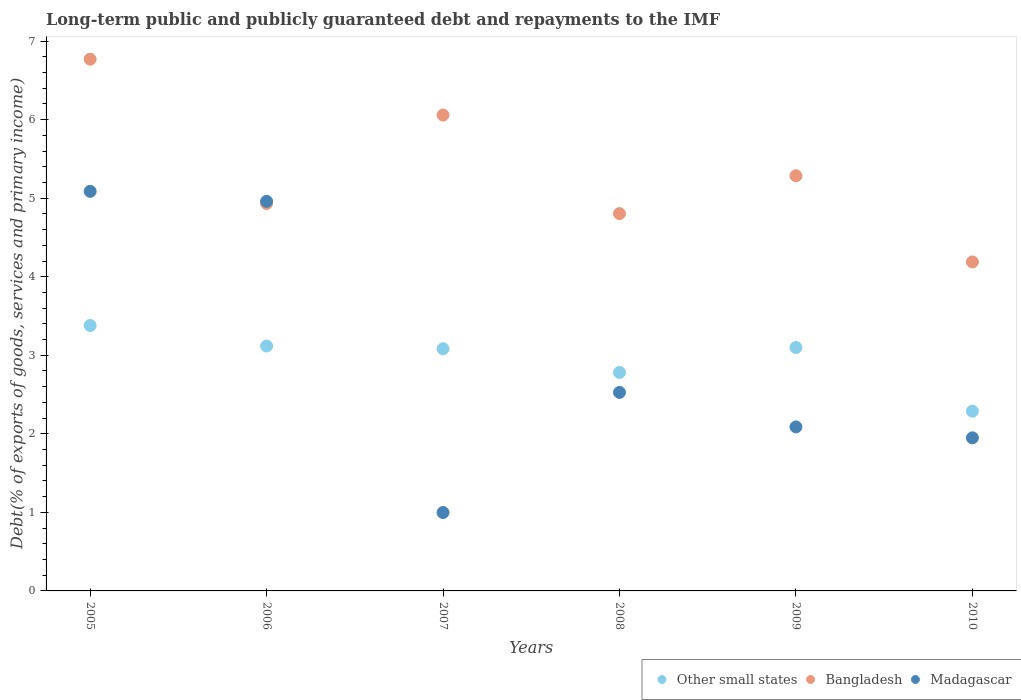What is the debt and repayments in Other small states in 2005?
Ensure brevity in your answer.  3.38. Across all years, what is the maximum debt and repayments in Other small states?
Provide a short and direct response. 3.38. Across all years, what is the minimum debt and repayments in Madagascar?
Provide a succinct answer. 1. In which year was the debt and repayments in Madagascar maximum?
Provide a succinct answer. 2005. What is the total debt and repayments in Other small states in the graph?
Make the answer very short. 17.75. What is the difference between the debt and repayments in Madagascar in 2006 and that in 2008?
Provide a succinct answer. 2.43. What is the difference between the debt and repayments in Other small states in 2006 and the debt and repayments in Bangladesh in 2005?
Offer a terse response. -3.65. What is the average debt and repayments in Madagascar per year?
Give a very brief answer. 2.93. In the year 2005, what is the difference between the debt and repayments in Other small states and debt and repayments in Bangladesh?
Make the answer very short. -3.39. What is the ratio of the debt and repayments in Other small states in 2006 to that in 2008?
Provide a short and direct response. 1.12. Is the debt and repayments in Bangladesh in 2007 less than that in 2008?
Offer a very short reply. No. Is the difference between the debt and repayments in Other small states in 2005 and 2010 greater than the difference between the debt and repayments in Bangladesh in 2005 and 2010?
Give a very brief answer. No. What is the difference between the highest and the second highest debt and repayments in Madagascar?
Provide a short and direct response. 0.13. What is the difference between the highest and the lowest debt and repayments in Bangladesh?
Make the answer very short. 2.58. Is the sum of the debt and repayments in Other small states in 2005 and 2010 greater than the maximum debt and repayments in Madagascar across all years?
Provide a short and direct response. Yes. Is it the case that in every year, the sum of the debt and repayments in Madagascar and debt and repayments in Other small states  is greater than the debt and repayments in Bangladesh?
Make the answer very short. No. Is the debt and repayments in Madagascar strictly less than the debt and repayments in Other small states over the years?
Keep it short and to the point. No. How many dotlines are there?
Your response must be concise. 3. What is the difference between two consecutive major ticks on the Y-axis?
Offer a terse response. 1. Are the values on the major ticks of Y-axis written in scientific E-notation?
Keep it short and to the point. No. Does the graph contain any zero values?
Offer a very short reply. No. Does the graph contain grids?
Offer a very short reply. No. What is the title of the graph?
Keep it short and to the point. Long-term public and publicly guaranteed debt and repayments to the IMF. What is the label or title of the X-axis?
Provide a succinct answer. Years. What is the label or title of the Y-axis?
Keep it short and to the point. Debt(% of exports of goods, services and primary income). What is the Debt(% of exports of goods, services and primary income) of Other small states in 2005?
Ensure brevity in your answer.  3.38. What is the Debt(% of exports of goods, services and primary income) of Bangladesh in 2005?
Make the answer very short. 6.77. What is the Debt(% of exports of goods, services and primary income) of Madagascar in 2005?
Offer a very short reply. 5.09. What is the Debt(% of exports of goods, services and primary income) of Other small states in 2006?
Ensure brevity in your answer.  3.12. What is the Debt(% of exports of goods, services and primary income) of Bangladesh in 2006?
Provide a succinct answer. 4.93. What is the Debt(% of exports of goods, services and primary income) in Madagascar in 2006?
Make the answer very short. 4.96. What is the Debt(% of exports of goods, services and primary income) in Other small states in 2007?
Offer a very short reply. 3.08. What is the Debt(% of exports of goods, services and primary income) in Bangladesh in 2007?
Your answer should be very brief. 6.06. What is the Debt(% of exports of goods, services and primary income) in Madagascar in 2007?
Make the answer very short. 1. What is the Debt(% of exports of goods, services and primary income) in Other small states in 2008?
Offer a terse response. 2.78. What is the Debt(% of exports of goods, services and primary income) in Bangladesh in 2008?
Offer a very short reply. 4.8. What is the Debt(% of exports of goods, services and primary income) of Madagascar in 2008?
Your answer should be compact. 2.53. What is the Debt(% of exports of goods, services and primary income) in Other small states in 2009?
Ensure brevity in your answer.  3.1. What is the Debt(% of exports of goods, services and primary income) in Bangladesh in 2009?
Provide a short and direct response. 5.29. What is the Debt(% of exports of goods, services and primary income) of Madagascar in 2009?
Your answer should be very brief. 2.09. What is the Debt(% of exports of goods, services and primary income) of Other small states in 2010?
Provide a succinct answer. 2.29. What is the Debt(% of exports of goods, services and primary income) in Bangladesh in 2010?
Provide a succinct answer. 4.19. What is the Debt(% of exports of goods, services and primary income) of Madagascar in 2010?
Provide a short and direct response. 1.95. Across all years, what is the maximum Debt(% of exports of goods, services and primary income) in Other small states?
Provide a short and direct response. 3.38. Across all years, what is the maximum Debt(% of exports of goods, services and primary income) in Bangladesh?
Your response must be concise. 6.77. Across all years, what is the maximum Debt(% of exports of goods, services and primary income) in Madagascar?
Your answer should be compact. 5.09. Across all years, what is the minimum Debt(% of exports of goods, services and primary income) in Other small states?
Provide a short and direct response. 2.29. Across all years, what is the minimum Debt(% of exports of goods, services and primary income) of Bangladesh?
Give a very brief answer. 4.19. Across all years, what is the minimum Debt(% of exports of goods, services and primary income) of Madagascar?
Provide a short and direct response. 1. What is the total Debt(% of exports of goods, services and primary income) of Other small states in the graph?
Provide a short and direct response. 17.75. What is the total Debt(% of exports of goods, services and primary income) of Bangladesh in the graph?
Keep it short and to the point. 32.04. What is the total Debt(% of exports of goods, services and primary income) in Madagascar in the graph?
Your answer should be compact. 17.61. What is the difference between the Debt(% of exports of goods, services and primary income) in Other small states in 2005 and that in 2006?
Provide a short and direct response. 0.26. What is the difference between the Debt(% of exports of goods, services and primary income) in Bangladesh in 2005 and that in 2006?
Ensure brevity in your answer.  1.84. What is the difference between the Debt(% of exports of goods, services and primary income) of Madagascar in 2005 and that in 2006?
Give a very brief answer. 0.13. What is the difference between the Debt(% of exports of goods, services and primary income) in Other small states in 2005 and that in 2007?
Your response must be concise. 0.3. What is the difference between the Debt(% of exports of goods, services and primary income) of Bangladesh in 2005 and that in 2007?
Your response must be concise. 0.71. What is the difference between the Debt(% of exports of goods, services and primary income) of Madagascar in 2005 and that in 2007?
Provide a short and direct response. 4.09. What is the difference between the Debt(% of exports of goods, services and primary income) of Other small states in 2005 and that in 2008?
Ensure brevity in your answer.  0.6. What is the difference between the Debt(% of exports of goods, services and primary income) in Bangladesh in 2005 and that in 2008?
Your answer should be compact. 1.97. What is the difference between the Debt(% of exports of goods, services and primary income) of Madagascar in 2005 and that in 2008?
Ensure brevity in your answer.  2.56. What is the difference between the Debt(% of exports of goods, services and primary income) in Other small states in 2005 and that in 2009?
Make the answer very short. 0.28. What is the difference between the Debt(% of exports of goods, services and primary income) of Bangladesh in 2005 and that in 2009?
Keep it short and to the point. 1.48. What is the difference between the Debt(% of exports of goods, services and primary income) of Madagascar in 2005 and that in 2009?
Offer a very short reply. 3. What is the difference between the Debt(% of exports of goods, services and primary income) of Other small states in 2005 and that in 2010?
Your response must be concise. 1.09. What is the difference between the Debt(% of exports of goods, services and primary income) in Bangladesh in 2005 and that in 2010?
Your answer should be compact. 2.58. What is the difference between the Debt(% of exports of goods, services and primary income) in Madagascar in 2005 and that in 2010?
Provide a succinct answer. 3.14. What is the difference between the Debt(% of exports of goods, services and primary income) in Other small states in 2006 and that in 2007?
Give a very brief answer. 0.03. What is the difference between the Debt(% of exports of goods, services and primary income) in Bangladesh in 2006 and that in 2007?
Offer a terse response. -1.13. What is the difference between the Debt(% of exports of goods, services and primary income) in Madagascar in 2006 and that in 2007?
Your response must be concise. 3.96. What is the difference between the Debt(% of exports of goods, services and primary income) in Other small states in 2006 and that in 2008?
Keep it short and to the point. 0.34. What is the difference between the Debt(% of exports of goods, services and primary income) of Bangladesh in 2006 and that in 2008?
Offer a very short reply. 0.13. What is the difference between the Debt(% of exports of goods, services and primary income) of Madagascar in 2006 and that in 2008?
Provide a short and direct response. 2.43. What is the difference between the Debt(% of exports of goods, services and primary income) in Other small states in 2006 and that in 2009?
Your answer should be compact. 0.02. What is the difference between the Debt(% of exports of goods, services and primary income) of Bangladesh in 2006 and that in 2009?
Give a very brief answer. -0.35. What is the difference between the Debt(% of exports of goods, services and primary income) in Madagascar in 2006 and that in 2009?
Offer a very short reply. 2.87. What is the difference between the Debt(% of exports of goods, services and primary income) in Other small states in 2006 and that in 2010?
Give a very brief answer. 0.83. What is the difference between the Debt(% of exports of goods, services and primary income) of Bangladesh in 2006 and that in 2010?
Your answer should be compact. 0.74. What is the difference between the Debt(% of exports of goods, services and primary income) in Madagascar in 2006 and that in 2010?
Keep it short and to the point. 3.01. What is the difference between the Debt(% of exports of goods, services and primary income) of Other small states in 2007 and that in 2008?
Offer a very short reply. 0.3. What is the difference between the Debt(% of exports of goods, services and primary income) of Bangladesh in 2007 and that in 2008?
Keep it short and to the point. 1.25. What is the difference between the Debt(% of exports of goods, services and primary income) of Madagascar in 2007 and that in 2008?
Your answer should be very brief. -1.53. What is the difference between the Debt(% of exports of goods, services and primary income) in Other small states in 2007 and that in 2009?
Your answer should be very brief. -0.02. What is the difference between the Debt(% of exports of goods, services and primary income) in Bangladesh in 2007 and that in 2009?
Offer a very short reply. 0.77. What is the difference between the Debt(% of exports of goods, services and primary income) of Madagascar in 2007 and that in 2009?
Give a very brief answer. -1.09. What is the difference between the Debt(% of exports of goods, services and primary income) of Other small states in 2007 and that in 2010?
Ensure brevity in your answer.  0.79. What is the difference between the Debt(% of exports of goods, services and primary income) of Bangladesh in 2007 and that in 2010?
Offer a very short reply. 1.87. What is the difference between the Debt(% of exports of goods, services and primary income) of Madagascar in 2007 and that in 2010?
Offer a very short reply. -0.95. What is the difference between the Debt(% of exports of goods, services and primary income) of Other small states in 2008 and that in 2009?
Your answer should be very brief. -0.32. What is the difference between the Debt(% of exports of goods, services and primary income) of Bangladesh in 2008 and that in 2009?
Your answer should be very brief. -0.48. What is the difference between the Debt(% of exports of goods, services and primary income) in Madagascar in 2008 and that in 2009?
Provide a succinct answer. 0.44. What is the difference between the Debt(% of exports of goods, services and primary income) of Other small states in 2008 and that in 2010?
Offer a very short reply. 0.49. What is the difference between the Debt(% of exports of goods, services and primary income) of Bangladesh in 2008 and that in 2010?
Your answer should be compact. 0.62. What is the difference between the Debt(% of exports of goods, services and primary income) in Madagascar in 2008 and that in 2010?
Give a very brief answer. 0.58. What is the difference between the Debt(% of exports of goods, services and primary income) of Other small states in 2009 and that in 2010?
Provide a succinct answer. 0.81. What is the difference between the Debt(% of exports of goods, services and primary income) of Bangladesh in 2009 and that in 2010?
Make the answer very short. 1.1. What is the difference between the Debt(% of exports of goods, services and primary income) of Madagascar in 2009 and that in 2010?
Provide a succinct answer. 0.14. What is the difference between the Debt(% of exports of goods, services and primary income) of Other small states in 2005 and the Debt(% of exports of goods, services and primary income) of Bangladesh in 2006?
Provide a short and direct response. -1.55. What is the difference between the Debt(% of exports of goods, services and primary income) in Other small states in 2005 and the Debt(% of exports of goods, services and primary income) in Madagascar in 2006?
Your response must be concise. -1.58. What is the difference between the Debt(% of exports of goods, services and primary income) in Bangladesh in 2005 and the Debt(% of exports of goods, services and primary income) in Madagascar in 2006?
Keep it short and to the point. 1.81. What is the difference between the Debt(% of exports of goods, services and primary income) of Other small states in 2005 and the Debt(% of exports of goods, services and primary income) of Bangladesh in 2007?
Your response must be concise. -2.68. What is the difference between the Debt(% of exports of goods, services and primary income) of Other small states in 2005 and the Debt(% of exports of goods, services and primary income) of Madagascar in 2007?
Provide a short and direct response. 2.38. What is the difference between the Debt(% of exports of goods, services and primary income) of Bangladesh in 2005 and the Debt(% of exports of goods, services and primary income) of Madagascar in 2007?
Your response must be concise. 5.77. What is the difference between the Debt(% of exports of goods, services and primary income) of Other small states in 2005 and the Debt(% of exports of goods, services and primary income) of Bangladesh in 2008?
Your answer should be compact. -1.42. What is the difference between the Debt(% of exports of goods, services and primary income) of Other small states in 2005 and the Debt(% of exports of goods, services and primary income) of Madagascar in 2008?
Your answer should be very brief. 0.85. What is the difference between the Debt(% of exports of goods, services and primary income) of Bangladesh in 2005 and the Debt(% of exports of goods, services and primary income) of Madagascar in 2008?
Ensure brevity in your answer.  4.24. What is the difference between the Debt(% of exports of goods, services and primary income) of Other small states in 2005 and the Debt(% of exports of goods, services and primary income) of Bangladesh in 2009?
Offer a very short reply. -1.91. What is the difference between the Debt(% of exports of goods, services and primary income) of Other small states in 2005 and the Debt(% of exports of goods, services and primary income) of Madagascar in 2009?
Offer a very short reply. 1.29. What is the difference between the Debt(% of exports of goods, services and primary income) in Bangladesh in 2005 and the Debt(% of exports of goods, services and primary income) in Madagascar in 2009?
Provide a short and direct response. 4.68. What is the difference between the Debt(% of exports of goods, services and primary income) of Other small states in 2005 and the Debt(% of exports of goods, services and primary income) of Bangladesh in 2010?
Provide a short and direct response. -0.81. What is the difference between the Debt(% of exports of goods, services and primary income) of Other small states in 2005 and the Debt(% of exports of goods, services and primary income) of Madagascar in 2010?
Your answer should be very brief. 1.43. What is the difference between the Debt(% of exports of goods, services and primary income) in Bangladesh in 2005 and the Debt(% of exports of goods, services and primary income) in Madagascar in 2010?
Make the answer very short. 4.82. What is the difference between the Debt(% of exports of goods, services and primary income) of Other small states in 2006 and the Debt(% of exports of goods, services and primary income) of Bangladesh in 2007?
Make the answer very short. -2.94. What is the difference between the Debt(% of exports of goods, services and primary income) in Other small states in 2006 and the Debt(% of exports of goods, services and primary income) in Madagascar in 2007?
Your response must be concise. 2.12. What is the difference between the Debt(% of exports of goods, services and primary income) of Bangladesh in 2006 and the Debt(% of exports of goods, services and primary income) of Madagascar in 2007?
Ensure brevity in your answer.  3.93. What is the difference between the Debt(% of exports of goods, services and primary income) of Other small states in 2006 and the Debt(% of exports of goods, services and primary income) of Bangladesh in 2008?
Provide a short and direct response. -1.69. What is the difference between the Debt(% of exports of goods, services and primary income) of Other small states in 2006 and the Debt(% of exports of goods, services and primary income) of Madagascar in 2008?
Offer a very short reply. 0.59. What is the difference between the Debt(% of exports of goods, services and primary income) of Bangladesh in 2006 and the Debt(% of exports of goods, services and primary income) of Madagascar in 2008?
Ensure brevity in your answer.  2.41. What is the difference between the Debt(% of exports of goods, services and primary income) in Other small states in 2006 and the Debt(% of exports of goods, services and primary income) in Bangladesh in 2009?
Provide a short and direct response. -2.17. What is the difference between the Debt(% of exports of goods, services and primary income) in Other small states in 2006 and the Debt(% of exports of goods, services and primary income) in Madagascar in 2009?
Your response must be concise. 1.03. What is the difference between the Debt(% of exports of goods, services and primary income) in Bangladesh in 2006 and the Debt(% of exports of goods, services and primary income) in Madagascar in 2009?
Make the answer very short. 2.84. What is the difference between the Debt(% of exports of goods, services and primary income) in Other small states in 2006 and the Debt(% of exports of goods, services and primary income) in Bangladesh in 2010?
Your answer should be very brief. -1.07. What is the difference between the Debt(% of exports of goods, services and primary income) in Other small states in 2006 and the Debt(% of exports of goods, services and primary income) in Madagascar in 2010?
Offer a terse response. 1.17. What is the difference between the Debt(% of exports of goods, services and primary income) of Bangladesh in 2006 and the Debt(% of exports of goods, services and primary income) of Madagascar in 2010?
Provide a succinct answer. 2.98. What is the difference between the Debt(% of exports of goods, services and primary income) in Other small states in 2007 and the Debt(% of exports of goods, services and primary income) in Bangladesh in 2008?
Make the answer very short. -1.72. What is the difference between the Debt(% of exports of goods, services and primary income) in Other small states in 2007 and the Debt(% of exports of goods, services and primary income) in Madagascar in 2008?
Your response must be concise. 0.56. What is the difference between the Debt(% of exports of goods, services and primary income) of Bangladesh in 2007 and the Debt(% of exports of goods, services and primary income) of Madagascar in 2008?
Offer a very short reply. 3.53. What is the difference between the Debt(% of exports of goods, services and primary income) in Other small states in 2007 and the Debt(% of exports of goods, services and primary income) in Bangladesh in 2009?
Give a very brief answer. -2.2. What is the difference between the Debt(% of exports of goods, services and primary income) in Other small states in 2007 and the Debt(% of exports of goods, services and primary income) in Madagascar in 2009?
Your response must be concise. 1. What is the difference between the Debt(% of exports of goods, services and primary income) of Bangladesh in 2007 and the Debt(% of exports of goods, services and primary income) of Madagascar in 2009?
Ensure brevity in your answer.  3.97. What is the difference between the Debt(% of exports of goods, services and primary income) of Other small states in 2007 and the Debt(% of exports of goods, services and primary income) of Bangladesh in 2010?
Your answer should be very brief. -1.11. What is the difference between the Debt(% of exports of goods, services and primary income) in Other small states in 2007 and the Debt(% of exports of goods, services and primary income) in Madagascar in 2010?
Your response must be concise. 1.13. What is the difference between the Debt(% of exports of goods, services and primary income) of Bangladesh in 2007 and the Debt(% of exports of goods, services and primary income) of Madagascar in 2010?
Your response must be concise. 4.11. What is the difference between the Debt(% of exports of goods, services and primary income) in Other small states in 2008 and the Debt(% of exports of goods, services and primary income) in Bangladesh in 2009?
Your answer should be compact. -2.5. What is the difference between the Debt(% of exports of goods, services and primary income) in Other small states in 2008 and the Debt(% of exports of goods, services and primary income) in Madagascar in 2009?
Provide a succinct answer. 0.69. What is the difference between the Debt(% of exports of goods, services and primary income) of Bangladesh in 2008 and the Debt(% of exports of goods, services and primary income) of Madagascar in 2009?
Offer a terse response. 2.72. What is the difference between the Debt(% of exports of goods, services and primary income) in Other small states in 2008 and the Debt(% of exports of goods, services and primary income) in Bangladesh in 2010?
Make the answer very short. -1.41. What is the difference between the Debt(% of exports of goods, services and primary income) in Other small states in 2008 and the Debt(% of exports of goods, services and primary income) in Madagascar in 2010?
Offer a very short reply. 0.83. What is the difference between the Debt(% of exports of goods, services and primary income) of Bangladesh in 2008 and the Debt(% of exports of goods, services and primary income) of Madagascar in 2010?
Your answer should be very brief. 2.85. What is the difference between the Debt(% of exports of goods, services and primary income) of Other small states in 2009 and the Debt(% of exports of goods, services and primary income) of Bangladesh in 2010?
Ensure brevity in your answer.  -1.09. What is the difference between the Debt(% of exports of goods, services and primary income) in Other small states in 2009 and the Debt(% of exports of goods, services and primary income) in Madagascar in 2010?
Provide a short and direct response. 1.15. What is the difference between the Debt(% of exports of goods, services and primary income) in Bangladesh in 2009 and the Debt(% of exports of goods, services and primary income) in Madagascar in 2010?
Ensure brevity in your answer.  3.34. What is the average Debt(% of exports of goods, services and primary income) of Other small states per year?
Your answer should be very brief. 2.96. What is the average Debt(% of exports of goods, services and primary income) in Bangladesh per year?
Your answer should be very brief. 5.34. What is the average Debt(% of exports of goods, services and primary income) in Madagascar per year?
Provide a succinct answer. 2.94. In the year 2005, what is the difference between the Debt(% of exports of goods, services and primary income) in Other small states and Debt(% of exports of goods, services and primary income) in Bangladesh?
Your answer should be compact. -3.39. In the year 2005, what is the difference between the Debt(% of exports of goods, services and primary income) in Other small states and Debt(% of exports of goods, services and primary income) in Madagascar?
Your response must be concise. -1.71. In the year 2005, what is the difference between the Debt(% of exports of goods, services and primary income) of Bangladesh and Debt(% of exports of goods, services and primary income) of Madagascar?
Your answer should be very brief. 1.68. In the year 2006, what is the difference between the Debt(% of exports of goods, services and primary income) in Other small states and Debt(% of exports of goods, services and primary income) in Bangladesh?
Offer a very short reply. -1.82. In the year 2006, what is the difference between the Debt(% of exports of goods, services and primary income) in Other small states and Debt(% of exports of goods, services and primary income) in Madagascar?
Provide a succinct answer. -1.84. In the year 2006, what is the difference between the Debt(% of exports of goods, services and primary income) of Bangladesh and Debt(% of exports of goods, services and primary income) of Madagascar?
Offer a terse response. -0.03. In the year 2007, what is the difference between the Debt(% of exports of goods, services and primary income) of Other small states and Debt(% of exports of goods, services and primary income) of Bangladesh?
Give a very brief answer. -2.98. In the year 2007, what is the difference between the Debt(% of exports of goods, services and primary income) in Other small states and Debt(% of exports of goods, services and primary income) in Madagascar?
Your response must be concise. 2.09. In the year 2007, what is the difference between the Debt(% of exports of goods, services and primary income) in Bangladesh and Debt(% of exports of goods, services and primary income) in Madagascar?
Offer a very short reply. 5.06. In the year 2008, what is the difference between the Debt(% of exports of goods, services and primary income) in Other small states and Debt(% of exports of goods, services and primary income) in Bangladesh?
Offer a very short reply. -2.02. In the year 2008, what is the difference between the Debt(% of exports of goods, services and primary income) of Other small states and Debt(% of exports of goods, services and primary income) of Madagascar?
Provide a short and direct response. 0.25. In the year 2008, what is the difference between the Debt(% of exports of goods, services and primary income) in Bangladesh and Debt(% of exports of goods, services and primary income) in Madagascar?
Offer a terse response. 2.28. In the year 2009, what is the difference between the Debt(% of exports of goods, services and primary income) in Other small states and Debt(% of exports of goods, services and primary income) in Bangladesh?
Your answer should be compact. -2.19. In the year 2009, what is the difference between the Debt(% of exports of goods, services and primary income) in Other small states and Debt(% of exports of goods, services and primary income) in Madagascar?
Offer a terse response. 1.01. In the year 2009, what is the difference between the Debt(% of exports of goods, services and primary income) of Bangladesh and Debt(% of exports of goods, services and primary income) of Madagascar?
Your answer should be compact. 3.2. In the year 2010, what is the difference between the Debt(% of exports of goods, services and primary income) of Other small states and Debt(% of exports of goods, services and primary income) of Bangladesh?
Make the answer very short. -1.9. In the year 2010, what is the difference between the Debt(% of exports of goods, services and primary income) in Other small states and Debt(% of exports of goods, services and primary income) in Madagascar?
Give a very brief answer. 0.34. In the year 2010, what is the difference between the Debt(% of exports of goods, services and primary income) in Bangladesh and Debt(% of exports of goods, services and primary income) in Madagascar?
Your answer should be compact. 2.24. What is the ratio of the Debt(% of exports of goods, services and primary income) of Other small states in 2005 to that in 2006?
Keep it short and to the point. 1.08. What is the ratio of the Debt(% of exports of goods, services and primary income) of Bangladesh in 2005 to that in 2006?
Provide a short and direct response. 1.37. What is the ratio of the Debt(% of exports of goods, services and primary income) of Madagascar in 2005 to that in 2006?
Offer a terse response. 1.03. What is the ratio of the Debt(% of exports of goods, services and primary income) in Other small states in 2005 to that in 2007?
Offer a very short reply. 1.1. What is the ratio of the Debt(% of exports of goods, services and primary income) in Bangladesh in 2005 to that in 2007?
Provide a short and direct response. 1.12. What is the ratio of the Debt(% of exports of goods, services and primary income) of Madagascar in 2005 to that in 2007?
Provide a short and direct response. 5.1. What is the ratio of the Debt(% of exports of goods, services and primary income) in Other small states in 2005 to that in 2008?
Your answer should be compact. 1.22. What is the ratio of the Debt(% of exports of goods, services and primary income) of Bangladesh in 2005 to that in 2008?
Provide a succinct answer. 1.41. What is the ratio of the Debt(% of exports of goods, services and primary income) in Madagascar in 2005 to that in 2008?
Offer a terse response. 2.01. What is the ratio of the Debt(% of exports of goods, services and primary income) in Other small states in 2005 to that in 2009?
Ensure brevity in your answer.  1.09. What is the ratio of the Debt(% of exports of goods, services and primary income) in Bangladesh in 2005 to that in 2009?
Provide a succinct answer. 1.28. What is the ratio of the Debt(% of exports of goods, services and primary income) of Madagascar in 2005 to that in 2009?
Your answer should be compact. 2.44. What is the ratio of the Debt(% of exports of goods, services and primary income) in Other small states in 2005 to that in 2010?
Offer a terse response. 1.48. What is the ratio of the Debt(% of exports of goods, services and primary income) in Bangladesh in 2005 to that in 2010?
Offer a very short reply. 1.62. What is the ratio of the Debt(% of exports of goods, services and primary income) of Madagascar in 2005 to that in 2010?
Provide a short and direct response. 2.61. What is the ratio of the Debt(% of exports of goods, services and primary income) in Other small states in 2006 to that in 2007?
Make the answer very short. 1.01. What is the ratio of the Debt(% of exports of goods, services and primary income) in Bangladesh in 2006 to that in 2007?
Ensure brevity in your answer.  0.81. What is the ratio of the Debt(% of exports of goods, services and primary income) in Madagascar in 2006 to that in 2007?
Make the answer very short. 4.97. What is the ratio of the Debt(% of exports of goods, services and primary income) of Other small states in 2006 to that in 2008?
Provide a succinct answer. 1.12. What is the ratio of the Debt(% of exports of goods, services and primary income) of Bangladesh in 2006 to that in 2008?
Give a very brief answer. 1.03. What is the ratio of the Debt(% of exports of goods, services and primary income) in Madagascar in 2006 to that in 2008?
Ensure brevity in your answer.  1.96. What is the ratio of the Debt(% of exports of goods, services and primary income) in Bangladesh in 2006 to that in 2009?
Provide a short and direct response. 0.93. What is the ratio of the Debt(% of exports of goods, services and primary income) of Madagascar in 2006 to that in 2009?
Keep it short and to the point. 2.38. What is the ratio of the Debt(% of exports of goods, services and primary income) in Other small states in 2006 to that in 2010?
Your answer should be compact. 1.36. What is the ratio of the Debt(% of exports of goods, services and primary income) of Bangladesh in 2006 to that in 2010?
Ensure brevity in your answer.  1.18. What is the ratio of the Debt(% of exports of goods, services and primary income) of Madagascar in 2006 to that in 2010?
Give a very brief answer. 2.55. What is the ratio of the Debt(% of exports of goods, services and primary income) in Other small states in 2007 to that in 2008?
Keep it short and to the point. 1.11. What is the ratio of the Debt(% of exports of goods, services and primary income) in Bangladesh in 2007 to that in 2008?
Your answer should be compact. 1.26. What is the ratio of the Debt(% of exports of goods, services and primary income) of Madagascar in 2007 to that in 2008?
Your response must be concise. 0.39. What is the ratio of the Debt(% of exports of goods, services and primary income) in Bangladesh in 2007 to that in 2009?
Offer a very short reply. 1.15. What is the ratio of the Debt(% of exports of goods, services and primary income) in Madagascar in 2007 to that in 2009?
Your answer should be compact. 0.48. What is the ratio of the Debt(% of exports of goods, services and primary income) of Other small states in 2007 to that in 2010?
Ensure brevity in your answer.  1.35. What is the ratio of the Debt(% of exports of goods, services and primary income) of Bangladesh in 2007 to that in 2010?
Give a very brief answer. 1.45. What is the ratio of the Debt(% of exports of goods, services and primary income) of Madagascar in 2007 to that in 2010?
Your answer should be very brief. 0.51. What is the ratio of the Debt(% of exports of goods, services and primary income) in Other small states in 2008 to that in 2009?
Your response must be concise. 0.9. What is the ratio of the Debt(% of exports of goods, services and primary income) of Bangladesh in 2008 to that in 2009?
Your answer should be very brief. 0.91. What is the ratio of the Debt(% of exports of goods, services and primary income) of Madagascar in 2008 to that in 2009?
Your answer should be compact. 1.21. What is the ratio of the Debt(% of exports of goods, services and primary income) in Other small states in 2008 to that in 2010?
Offer a very short reply. 1.22. What is the ratio of the Debt(% of exports of goods, services and primary income) of Bangladesh in 2008 to that in 2010?
Your answer should be very brief. 1.15. What is the ratio of the Debt(% of exports of goods, services and primary income) in Madagascar in 2008 to that in 2010?
Ensure brevity in your answer.  1.3. What is the ratio of the Debt(% of exports of goods, services and primary income) in Other small states in 2009 to that in 2010?
Provide a short and direct response. 1.35. What is the ratio of the Debt(% of exports of goods, services and primary income) of Bangladesh in 2009 to that in 2010?
Provide a short and direct response. 1.26. What is the ratio of the Debt(% of exports of goods, services and primary income) of Madagascar in 2009 to that in 2010?
Give a very brief answer. 1.07. What is the difference between the highest and the second highest Debt(% of exports of goods, services and primary income) in Other small states?
Your answer should be very brief. 0.26. What is the difference between the highest and the second highest Debt(% of exports of goods, services and primary income) in Bangladesh?
Ensure brevity in your answer.  0.71. What is the difference between the highest and the second highest Debt(% of exports of goods, services and primary income) of Madagascar?
Your answer should be very brief. 0.13. What is the difference between the highest and the lowest Debt(% of exports of goods, services and primary income) of Other small states?
Offer a terse response. 1.09. What is the difference between the highest and the lowest Debt(% of exports of goods, services and primary income) in Bangladesh?
Your answer should be very brief. 2.58. What is the difference between the highest and the lowest Debt(% of exports of goods, services and primary income) in Madagascar?
Your answer should be very brief. 4.09. 